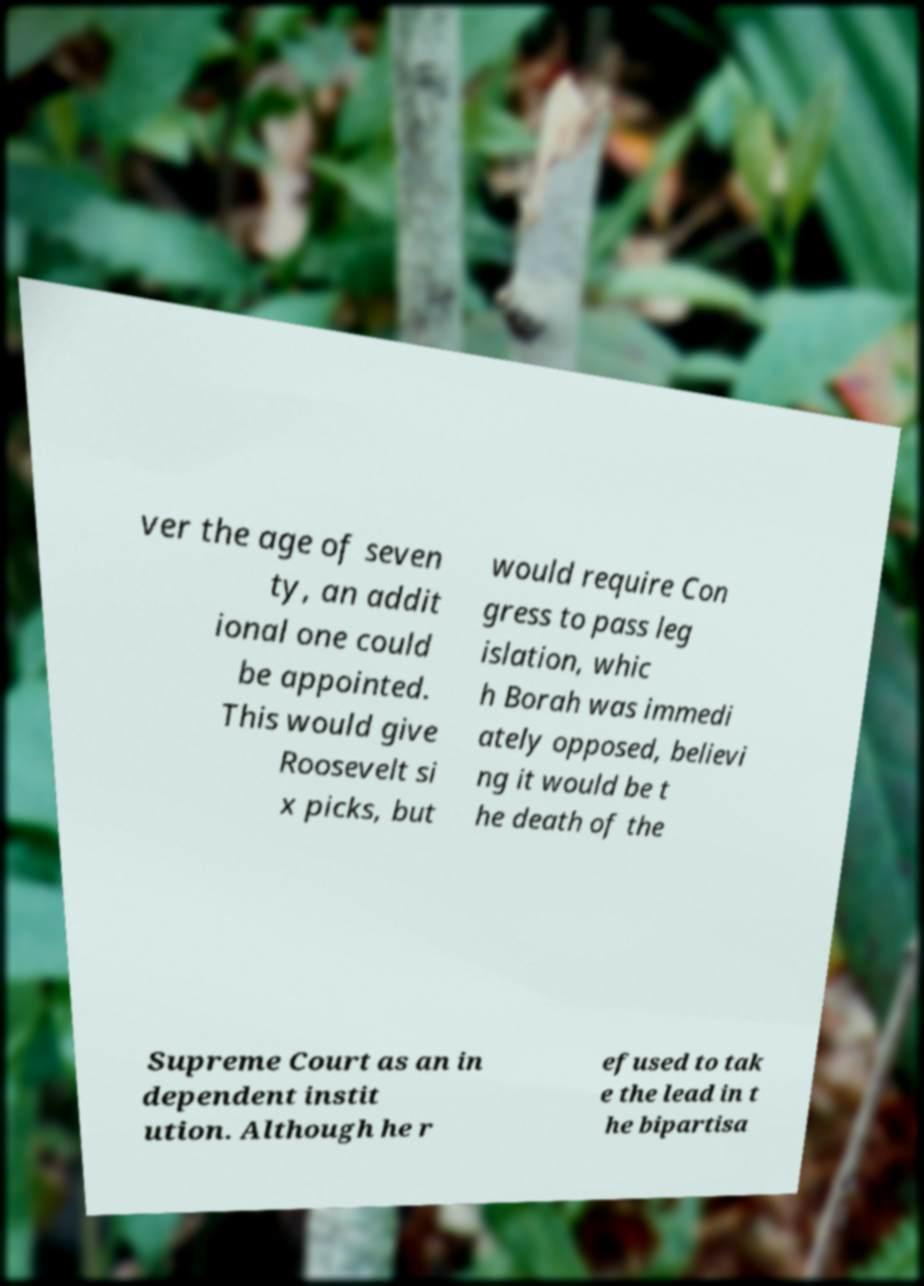Can you accurately transcribe the text from the provided image for me? ver the age of seven ty, an addit ional one could be appointed. This would give Roosevelt si x picks, but would require Con gress to pass leg islation, whic h Borah was immedi ately opposed, believi ng it would be t he death of the Supreme Court as an in dependent instit ution. Although he r efused to tak e the lead in t he bipartisa 